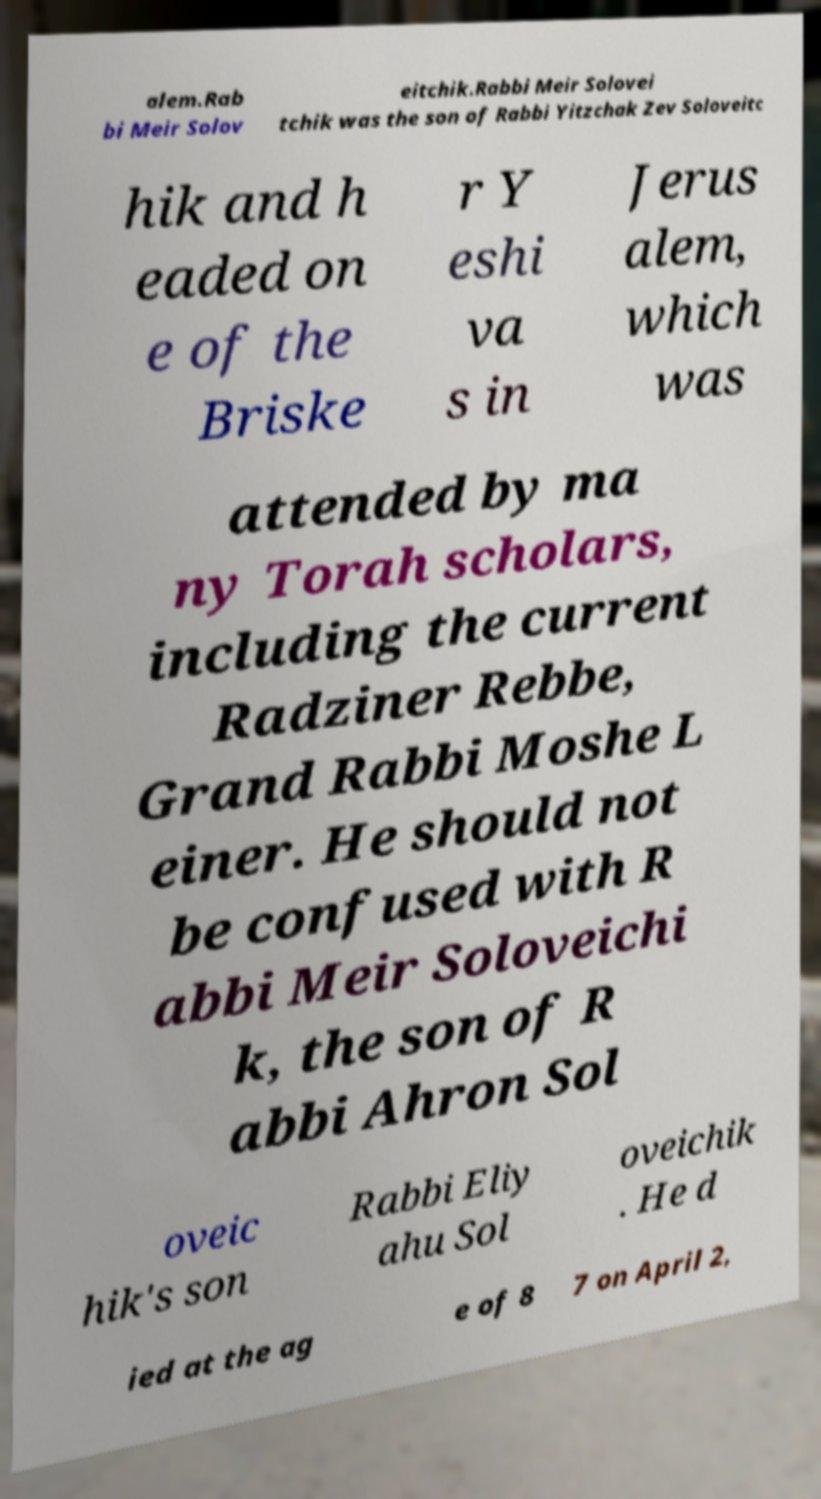Can you accurately transcribe the text from the provided image for me? alem.Rab bi Meir Solov eitchik.Rabbi Meir Solovei tchik was the son of Rabbi Yitzchak Zev Soloveitc hik and h eaded on e of the Briske r Y eshi va s in Jerus alem, which was attended by ma ny Torah scholars, including the current Radziner Rebbe, Grand Rabbi Moshe L einer. He should not be confused with R abbi Meir Soloveichi k, the son of R abbi Ahron Sol oveic hik's son Rabbi Eliy ahu Sol oveichik . He d ied at the ag e of 8 7 on April 2, 